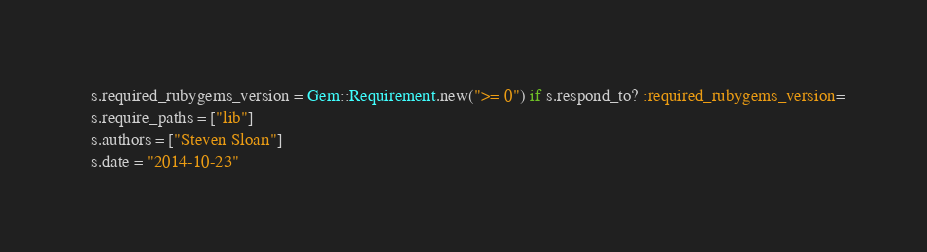Convert code to text. <code><loc_0><loc_0><loc_500><loc_500><_Ruby_>
  s.required_rubygems_version = Gem::Requirement.new(">= 0") if s.respond_to? :required_rubygems_version=
  s.require_paths = ["lib"]
  s.authors = ["Steven Sloan"]
  s.date = "2014-10-23"</code> 